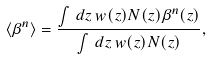Convert formula to latex. <formula><loc_0><loc_0><loc_500><loc_500>\langle \beta ^ { n } \rangle = \frac { \int \, d z \, w ( z ) N ( z ) \beta ^ { n } ( z ) } { \int \, d z \, w ( z ) N ( z ) } ,</formula> 